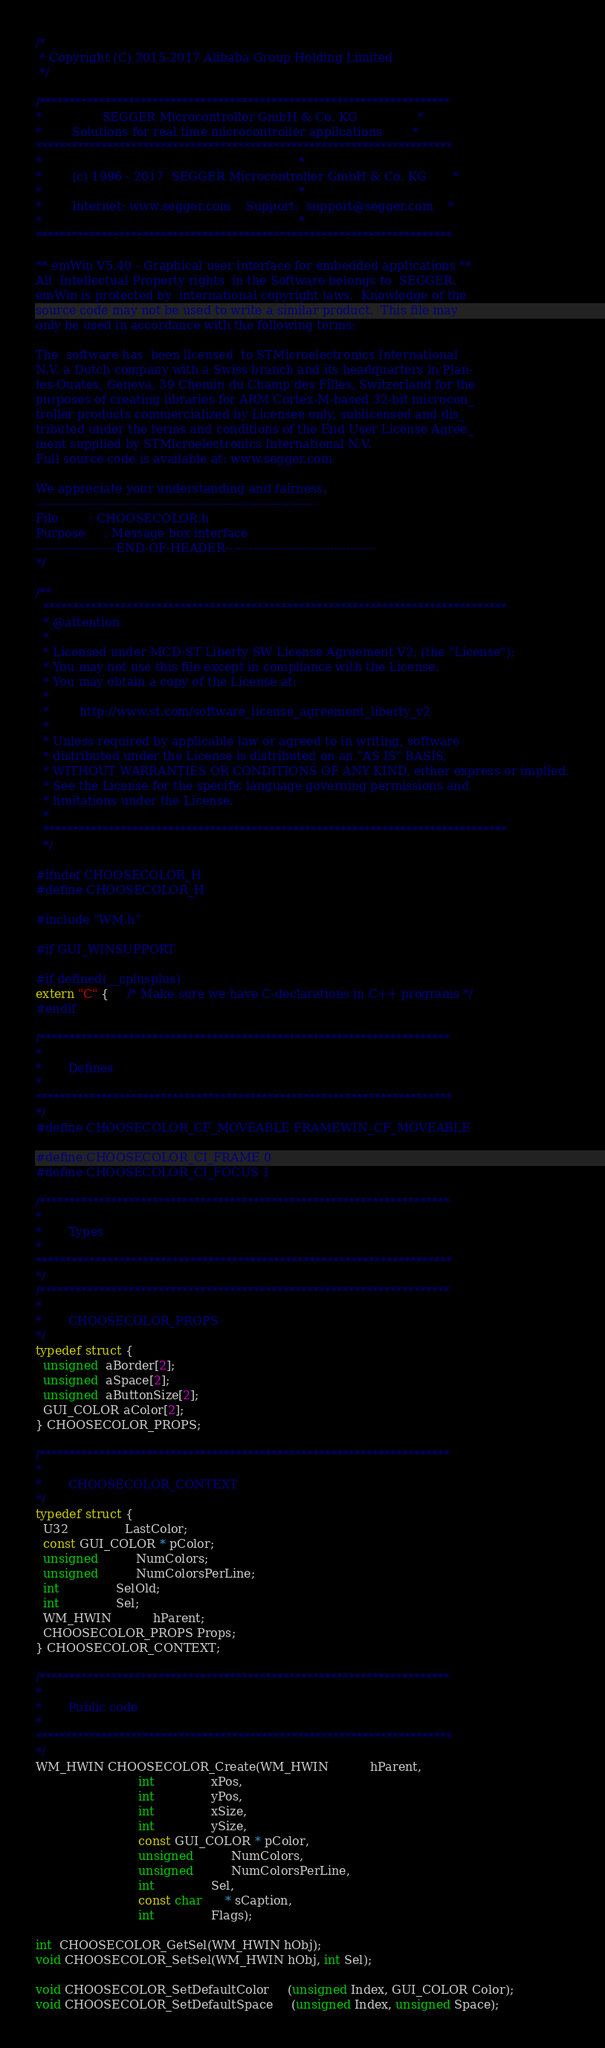Convert code to text. <code><loc_0><loc_0><loc_500><loc_500><_C_>/*
 * Copyright (C) 2015-2017 Alibaba Group Holding Limited
 */

/*********************************************************************
*                SEGGER Microcontroller GmbH & Co. KG                *
*        Solutions for real time microcontroller applications        *
**********************************************************************
*                                                                    *
*        (c) 1996 - 2017  SEGGER Microcontroller GmbH & Co. KG       *
*                                                                    *
*        Internet: www.segger.com    Support:  support@segger.com    *
*                                                                    *
**********************************************************************

** emWin V5.40 - Graphical user interface for embedded applications **
All  Intellectual Property rights  in the Software belongs to  SEGGER.
emWin is protected by  international copyright laws.  Knowledge of the
source code may not be used to write a similar product.  This file may
only be used in accordance with the following terms:

The  software has  been licensed  to STMicroelectronics International
N.V. a Dutch company with a Swiss branch and its headquarters in Plan-
les-Ouates, Geneva, 39 Chemin du Champ des Filles, Switzerland for the
purposes of creating libraries for ARM Cortex-M-based 32-bit microcon_
troller products commercialized by Licensee only, sublicensed and dis_
tributed under the terms and conditions of the End User License Agree_
ment supplied by STMicroelectronics International N.V.
Full source code is available at: www.segger.com

We appreciate your understanding and fairness.
----------------------------------------------------------------------
File        : CHOOSECOLOR.h
Purpose     : Message box interface
--------------------END-OF-HEADER-------------------------------------
*/

/**
  ******************************************************************************
  * @attention
  *
  * Licensed under MCD-ST Liberty SW License Agreement V2, (the "License");
  * You may not use this file except in compliance with the License.
  * You may obtain a copy of the License at:
  *
  *        http://www.st.com/software_license_agreement_liberty_v2
  *
  * Unless required by applicable law or agreed to in writing, software 
  * distributed under the License is distributed on an "AS IS" BASIS, 
  * WITHOUT WARRANTIES OR CONDITIONS OF ANY KIND, either express or implied.
  * See the License for the specific language governing permissions and
  * limitations under the License.
  *
  ******************************************************************************
  */
  
#ifndef CHOOSECOLOR_H
#define CHOOSECOLOR_H

#include "WM.h"

#if GUI_WINSUPPORT

#if defined(__cplusplus)
extern "C" {     /* Make sure we have C-declarations in C++ programs */
#endif

/*********************************************************************
*
*       Defines
*
**********************************************************************
*/
#define CHOOSECOLOR_CF_MOVEABLE FRAMEWIN_CF_MOVEABLE

#define CHOOSECOLOR_CI_FRAME 0
#define CHOOSECOLOR_CI_FOCUS 1

/*********************************************************************
*
*       Types
*
**********************************************************************
*/
/*********************************************************************
*
*       CHOOSECOLOR_PROPS
*/
typedef struct {
  unsigned  aBorder[2];
  unsigned  aSpace[2];
  unsigned  aButtonSize[2];
  GUI_COLOR aColor[2];
} CHOOSECOLOR_PROPS;

/*********************************************************************
*
*       CHOOSECOLOR_CONTEXT
*/
typedef struct {
  U32               LastColor;
  const GUI_COLOR * pColor;
  unsigned          NumColors;
  unsigned          NumColorsPerLine;
  int               SelOld;
  int               Sel;
  WM_HWIN           hParent;
  CHOOSECOLOR_PROPS Props;
} CHOOSECOLOR_CONTEXT;

/*********************************************************************
*
*       Public code
*
**********************************************************************
*/
WM_HWIN CHOOSECOLOR_Create(WM_HWIN           hParent,
                           int               xPos,
                           int               yPos,
                           int               xSize,
                           int               ySize,
                           const GUI_COLOR * pColor,
                           unsigned          NumColors,
                           unsigned          NumColorsPerLine,
                           int               Sel,
                           const char      * sCaption,
                           int               Flags);

int  CHOOSECOLOR_GetSel(WM_HWIN hObj);
void CHOOSECOLOR_SetSel(WM_HWIN hObj, int Sel);

void CHOOSECOLOR_SetDefaultColor     (unsigned Index, GUI_COLOR Color);
void CHOOSECOLOR_SetDefaultSpace     (unsigned Index, unsigned Space);</code> 